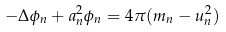<formula> <loc_0><loc_0><loc_500><loc_500>- \Delta \phi _ { n } + a _ { n } ^ { 2 } \phi _ { n } = 4 \pi ( m _ { n } - u _ { n } ^ { 2 } )</formula> 